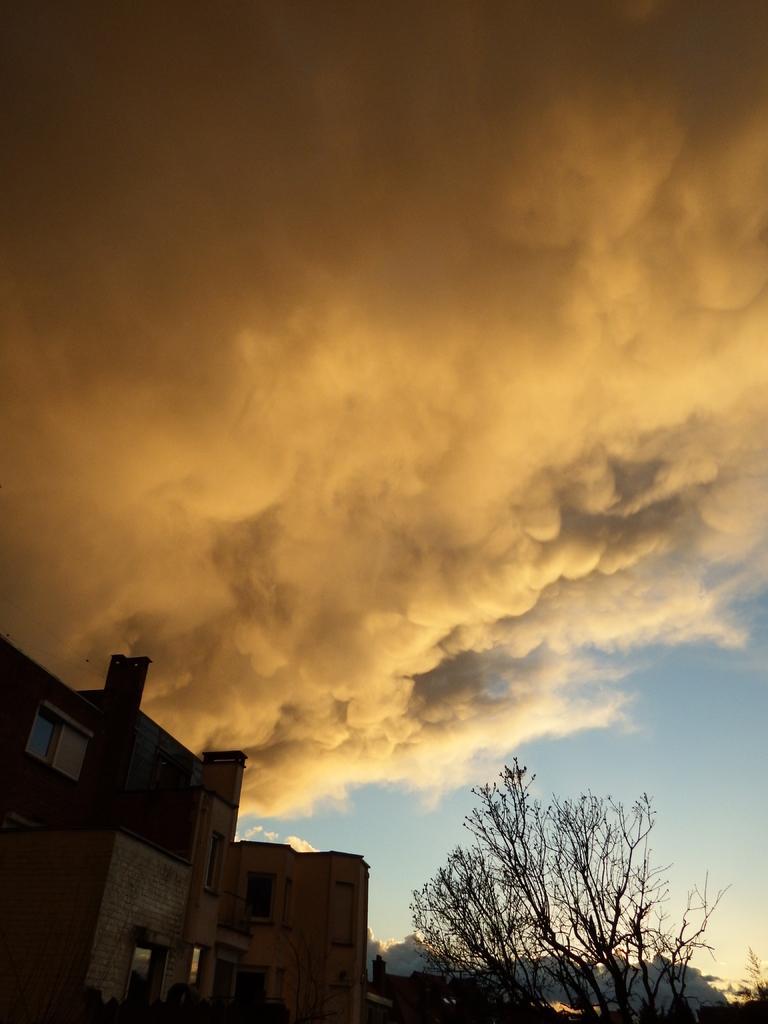How would you summarize this image in a sentence or two? At the bottom of the image there are buildings. On the right there is a tree. At the top we can see smoke and sky. 